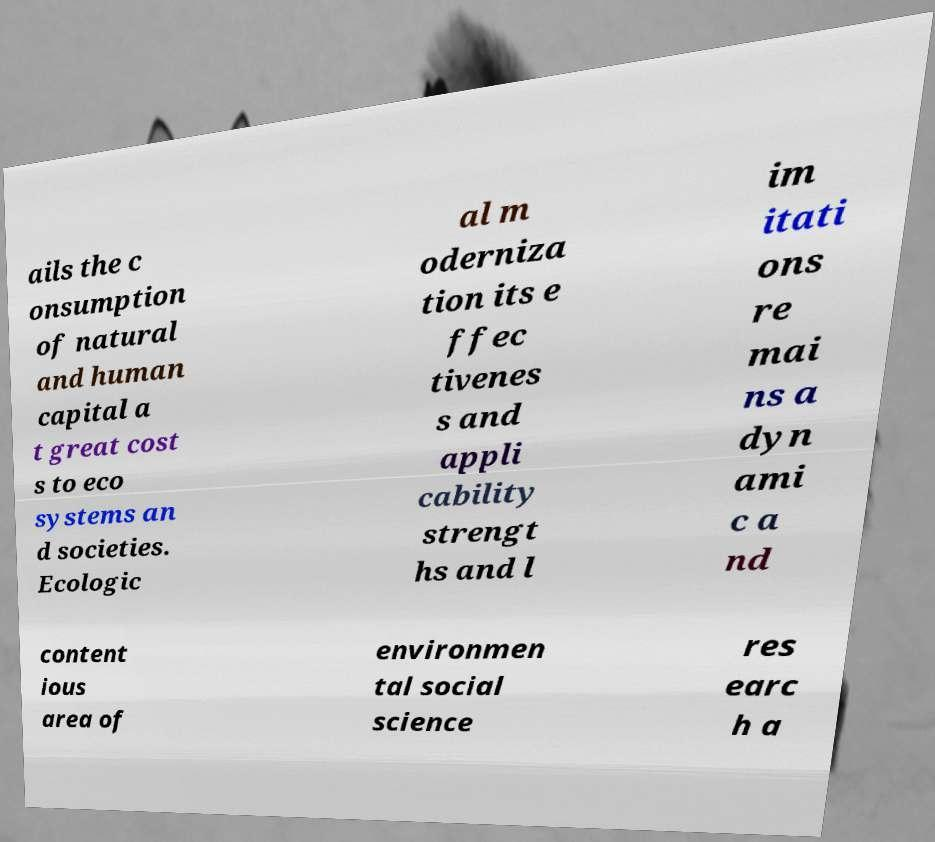I need the written content from this picture converted into text. Can you do that? ails the c onsumption of natural and human capital a t great cost s to eco systems an d societies. Ecologic al m oderniza tion its e ffec tivenes s and appli cability strengt hs and l im itati ons re mai ns a dyn ami c a nd content ious area of environmen tal social science res earc h a 